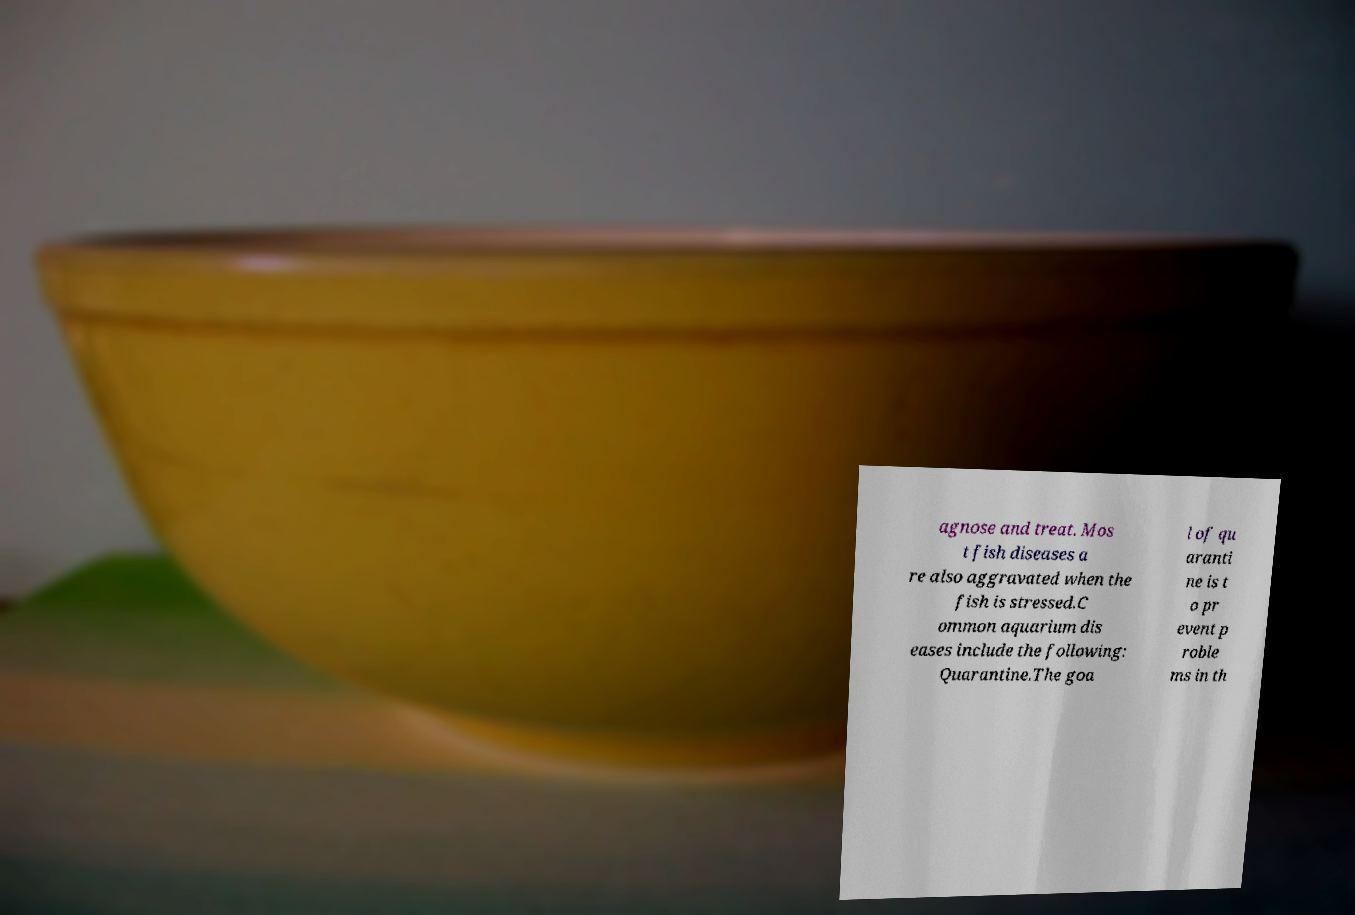What messages or text are displayed in this image? I need them in a readable, typed format. agnose and treat. Mos t fish diseases a re also aggravated when the fish is stressed.C ommon aquarium dis eases include the following: Quarantine.The goa l of qu aranti ne is t o pr event p roble ms in th 